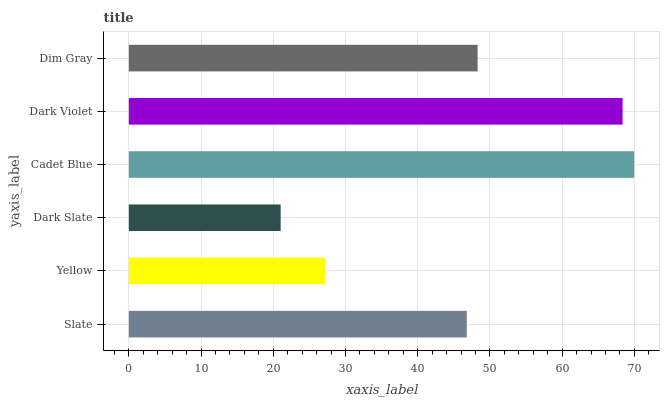Is Dark Slate the minimum?
Answer yes or no. Yes. Is Cadet Blue the maximum?
Answer yes or no. Yes. Is Yellow the minimum?
Answer yes or no. No. Is Yellow the maximum?
Answer yes or no. No. Is Slate greater than Yellow?
Answer yes or no. Yes. Is Yellow less than Slate?
Answer yes or no. Yes. Is Yellow greater than Slate?
Answer yes or no. No. Is Slate less than Yellow?
Answer yes or no. No. Is Dim Gray the high median?
Answer yes or no. Yes. Is Slate the low median?
Answer yes or no. Yes. Is Cadet Blue the high median?
Answer yes or no. No. Is Cadet Blue the low median?
Answer yes or no. No. 